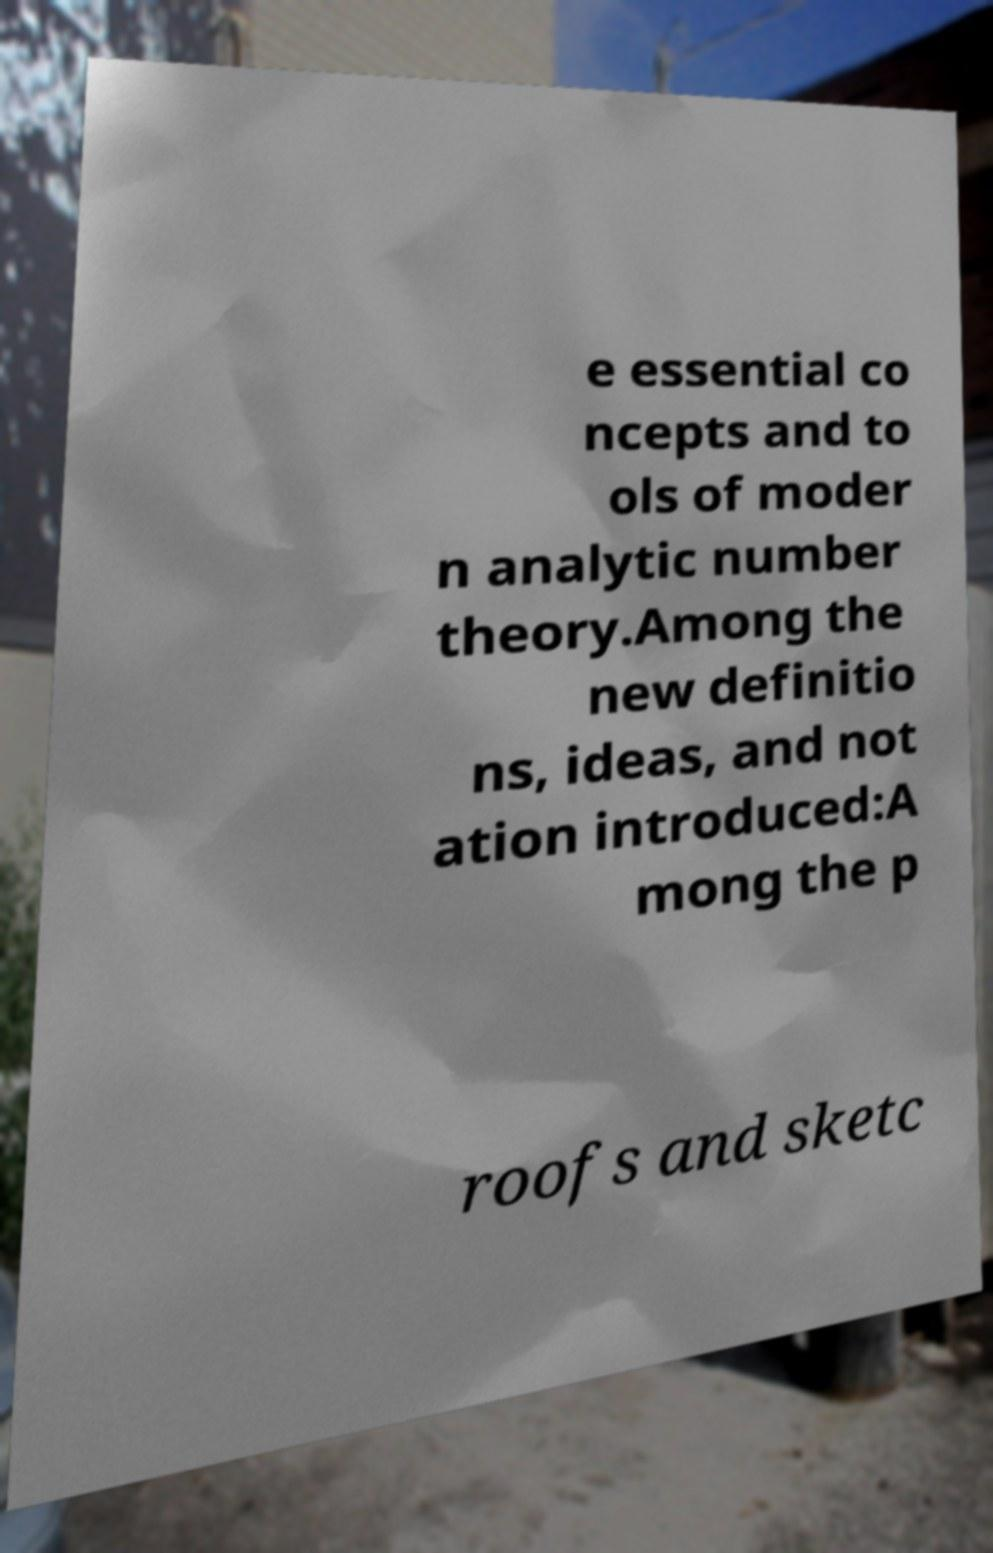What messages or text are displayed in this image? I need them in a readable, typed format. e essential co ncepts and to ols of moder n analytic number theory.Among the new definitio ns, ideas, and not ation introduced:A mong the p roofs and sketc 